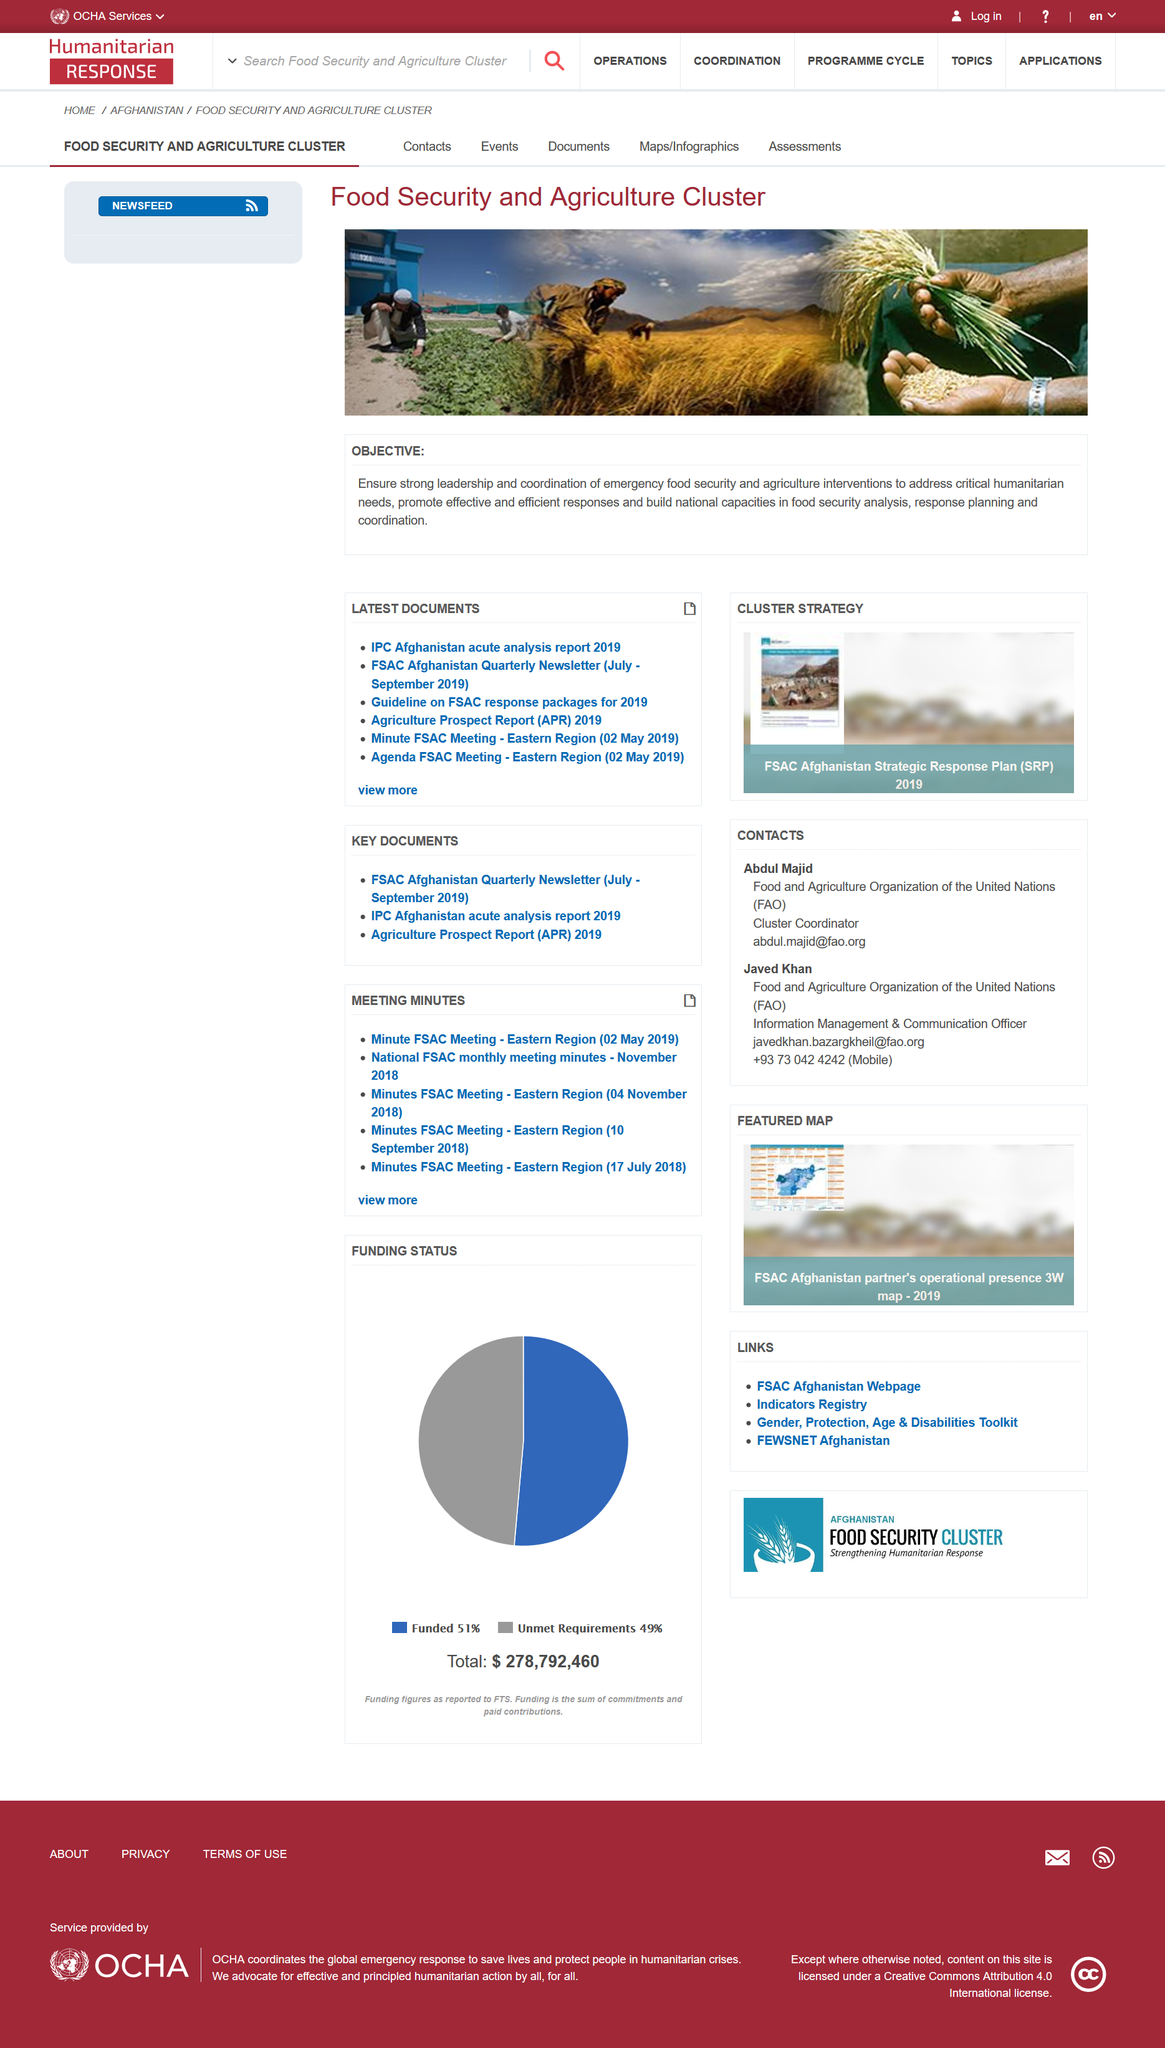Give some essential details in this illustration. Promoting effective and efficient responses is an objective of the program, with the aim of achieving the objective. The Food Security and Agriculture Cluster's objective includes striving for strong leadership. Yes, building national capacities in food security analysis is a key objective of the organization. 